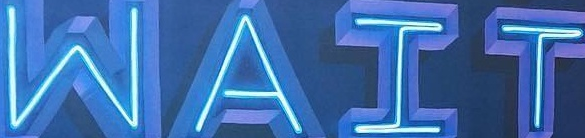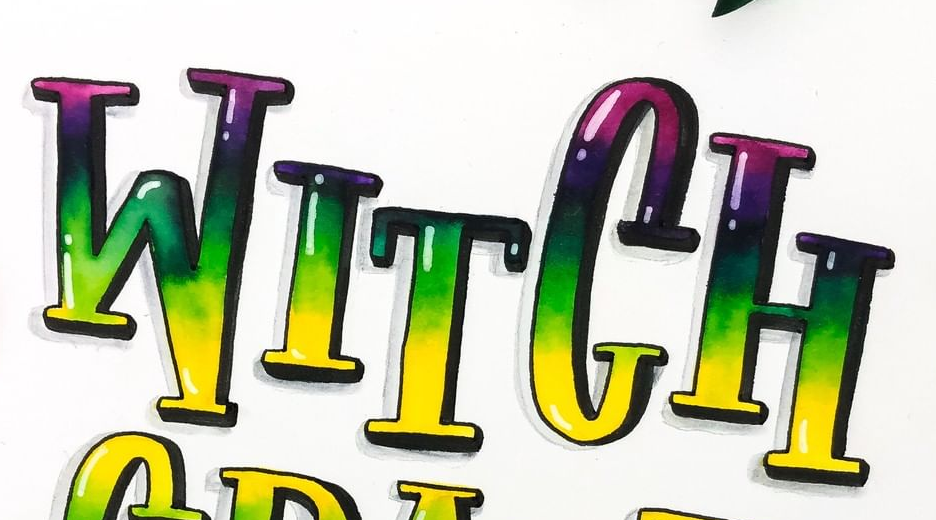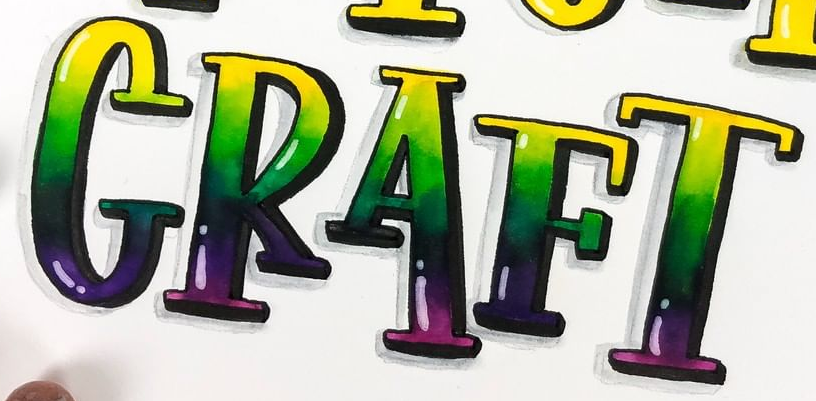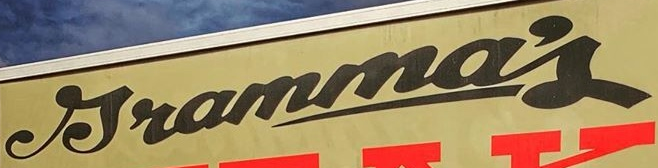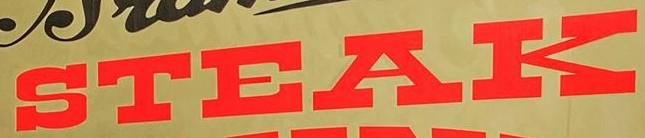What words can you see in these images in sequence, separated by a semicolon? WAIT; WITCH; CRAFT; Jramma's; STEAK 